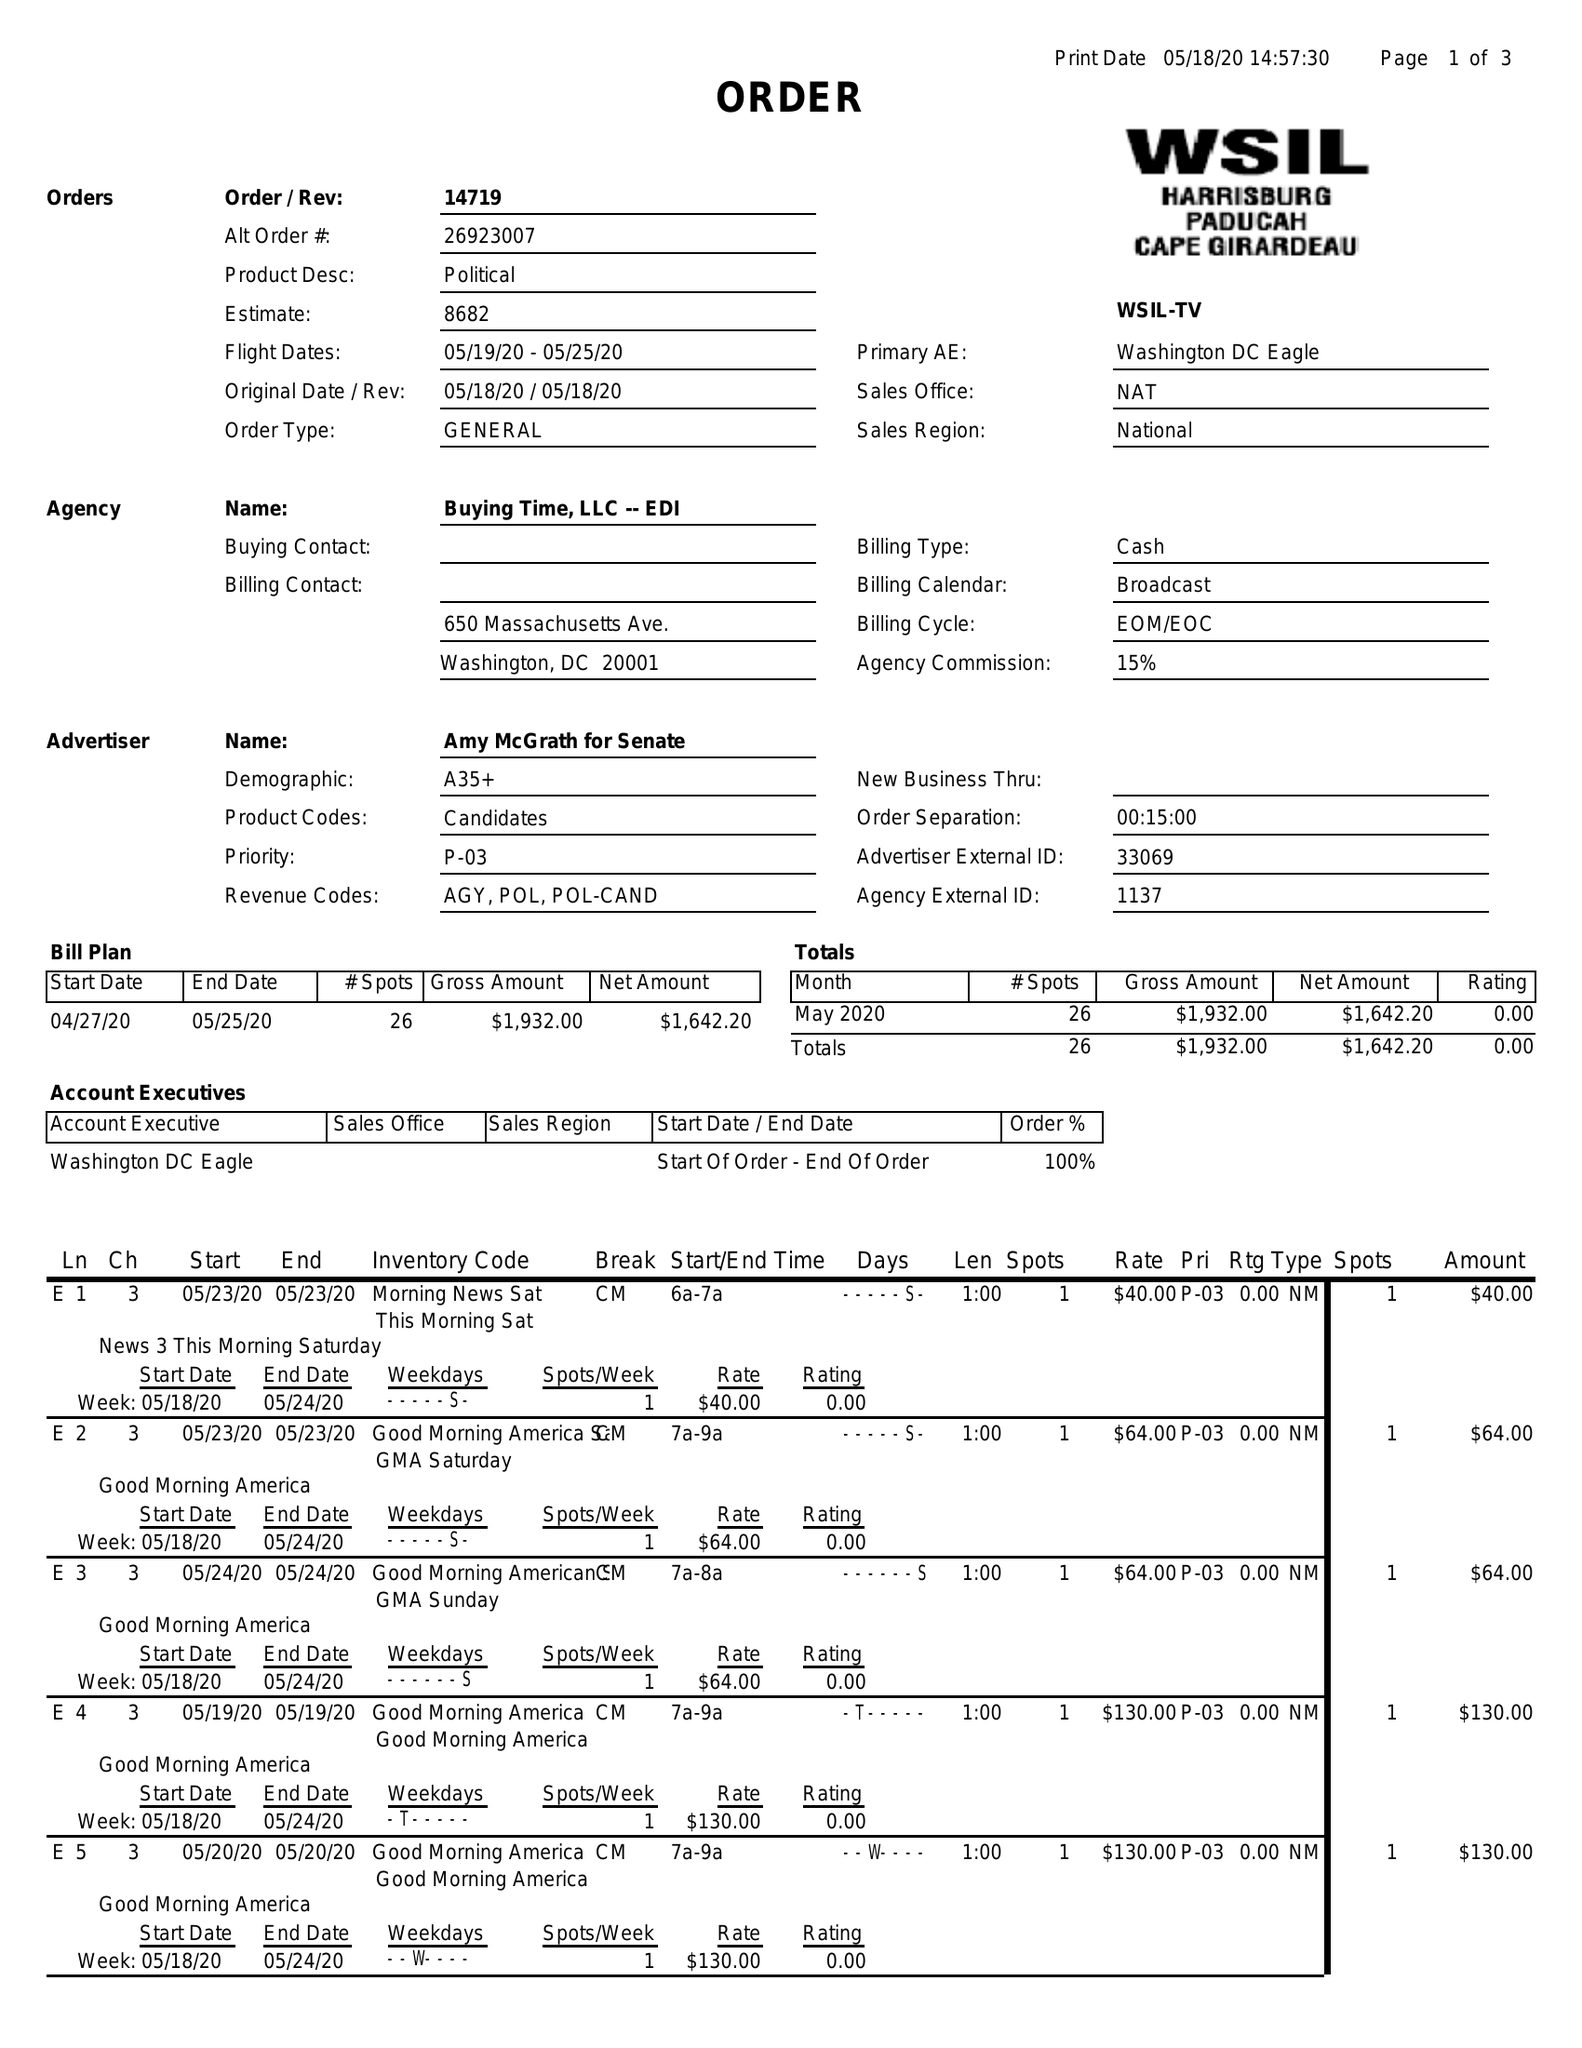What is the value for the advertiser?
Answer the question using a single word or phrase. AMY MCGRATH FOR SENATE 